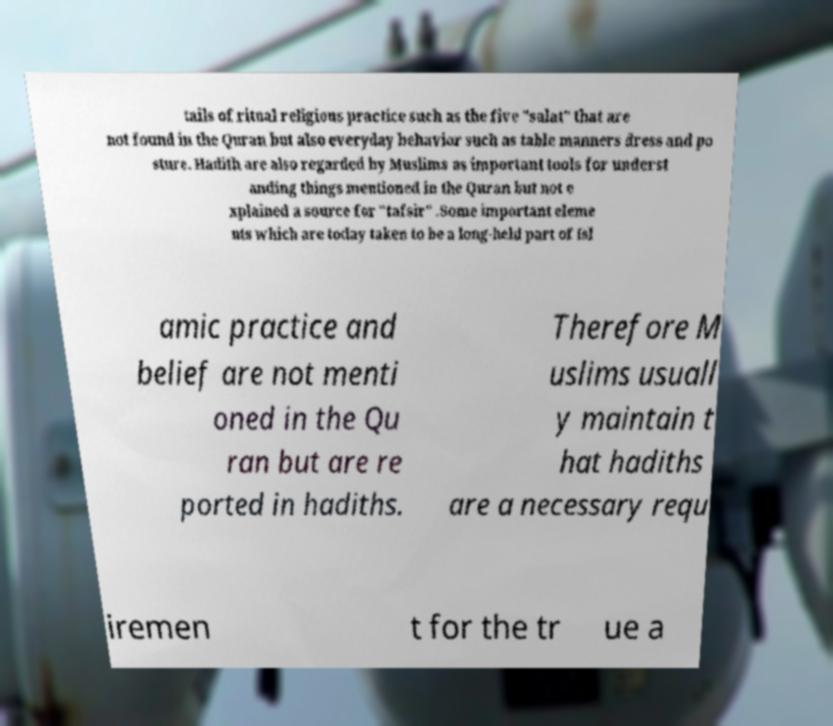Could you assist in decoding the text presented in this image and type it out clearly? tails of ritual religious practice such as the five "salat" that are not found in the Quran but also everyday behavior such as table manners dress and po sture. Hadith are also regarded by Muslims as important tools for underst anding things mentioned in the Quran but not e xplained a source for "tafsir" .Some important eleme nts which are today taken to be a long-held part of Isl amic practice and belief are not menti oned in the Qu ran but are re ported in hadiths. Therefore M uslims usuall y maintain t hat hadiths are a necessary requ iremen t for the tr ue a 